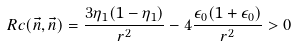<formula> <loc_0><loc_0><loc_500><loc_500>R c ( \vec { n } , \vec { n } ) = \frac { 3 \eta _ { 1 } ( 1 - \eta _ { 1 } ) } { r ^ { 2 } } - 4 \frac { \epsilon _ { 0 } ( 1 + \epsilon _ { 0 } ) } { r ^ { 2 } } > 0</formula> 